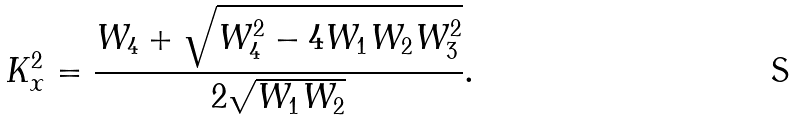<formula> <loc_0><loc_0><loc_500><loc_500>K _ { x } ^ { 2 } = \frac { W _ { 4 } + \sqrt { W _ { 4 } ^ { 2 } - 4 W _ { 1 } W _ { 2 } W _ { 3 } ^ { 2 } } } { 2 \sqrt { W _ { 1 } W _ { 2 } } } .</formula> 